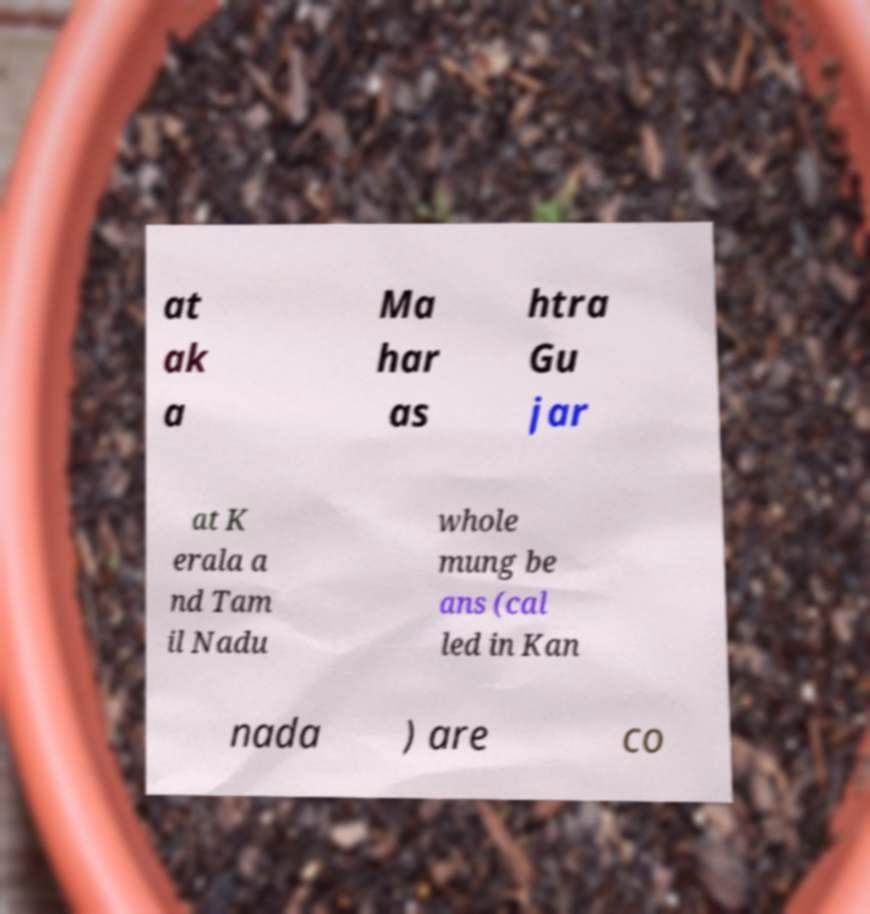Could you extract and type out the text from this image? at ak a Ma har as htra Gu jar at K erala a nd Tam il Nadu whole mung be ans (cal led in Kan nada ) are co 